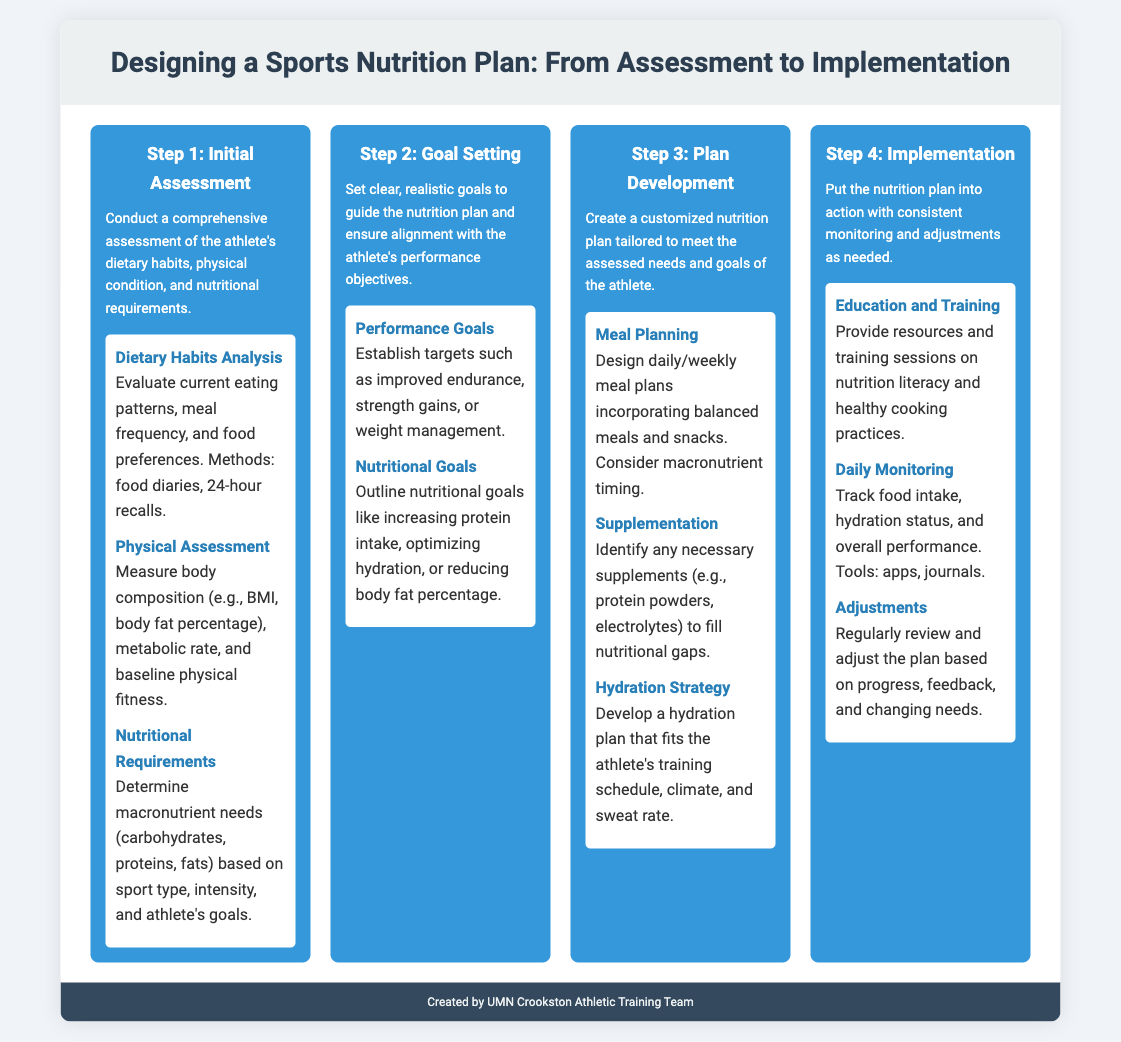What is the title of the infographic? The title of the infographic is found at the top of the document, which is central to the content and purpose.
Answer: Designing a Sports Nutrition Plan: From Assessment to Implementation How many steps are in the process? The number of steps is indicated by the distinct sections outlined in the infographic, each representing a different stage of the process.
Answer: 4 What is included in the Initial Assessment? The Initial Assessment step lists specific components that contribute to the overall evaluation of the athlete.
Answer: Dietary Habits Analysis, Physical Assessment, Nutritional Requirements What does Goal Setting involve? Goal Setting includes stages that are specific to the nutrients and performance objectives of the athlete, indicating its focus.
Answer: Performance Goals, Nutritional Goals What is one aspect of Meal Planning? Meal Planning specifies a particular strategy for organizing diet and nutrition, essential for an athlete’s regimen.
Answer: Balanced meals and snacks What does the Implementation step focus on? Implementation focuses on the actions taken to ensure the nutrition plan is followed effectively, highlighting its importance in the process.
Answer: Consistent monitoring and adjustments What is a tool mentioned for Daily Monitoring? Daily Monitoring lists a specific type of tool that can help track the athlete's nutrition and performance effectively.
Answer: Apps What type of education is provided in Implementation? The education provided in the Implementation phase centers on knowledge that supports dietary habits and practices of athletes.
Answer: Nutrition literacy and healthy cooking practices What is a key component of the Hydration Strategy? The Hydration Strategy includes specific guidelines tailored to the athlete's requirements, evident from the structured approach taken.
Answer: Fits the athlete's training schedule 